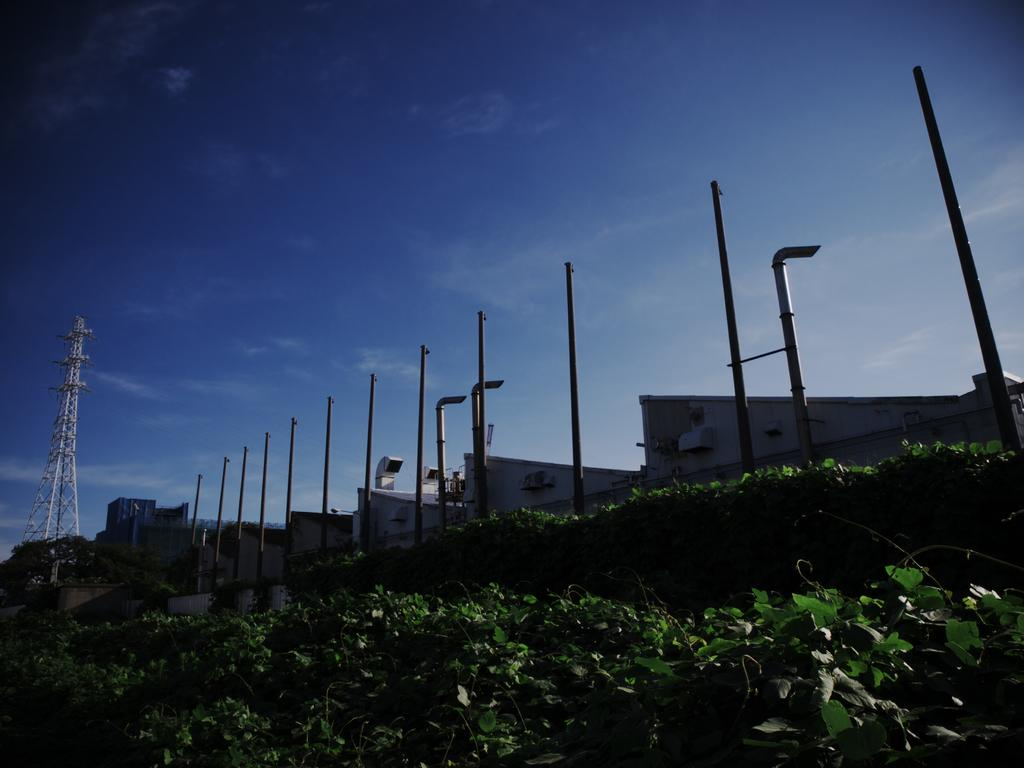What type of vegetation is at the bottom of the image? There are plants at the bottom of the image. What industrial elements are present in the middle of the image? Iron rods and exhaust pipes are present in the middle of the image. What structure is located on the left side of the image? There is a tower on the left side of the image. What is visible at the top of the image? The sky is visible at the top of the image. What statement is being made by the bat in the image? There is no bat present in the image, so no statement can be made by a bat. How many parcels are visible in the image? There are no parcels present in the image. 